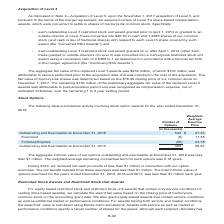According to Centurylink's financial document, What was the aggregate intrinsic value of options outstanding and exercisable at December 31, 2019?  less than $1 million. The document states: "standing and exercisable at December 31, 2019 was less than $1 million. The weighted-average remaining contractual term for such options was 0.18 year..." Also, What is the weighted-average remaining contractual term for options outstanding and exercisable? According to the financial document, 0.18 years. The relevant text states: "e remaining contractual term for such options was 0.18 years...." Also, What are the activity types involving stock option awards? The document shows two values: Exercised and Forfeited/Expired. From the document: "nd Exercisable at December 31, 2018 . 543 $ 27.46 Exercised . (6) 11.38 Forfeited/Expired . (68) 24.78 mber 31, 2018 . 543 $ 27.46 Exercised . (6) 11...." Additionally, Which year has a higher weighted-average exercise price for options outstanding and exercisable? According to the financial document, 2019. The relevant text states: "Outstanding and Exercisable at December 31, 2019 . 469 28.04..." Also, can you calculate: What is the change in the number of options outstanding and exercisable in 2019 from 2018? Based on the calculation: 469-543, the result is -74 (in thousands). This is based on the information: "utstanding and Exercisable at December 31, 2019 . 469 28.04 utstanding and Exercisable at December 31, 2018 . 543 $ 27.46 Exercised . (6) 11.38 Forfeited/Expired . (68) 24.78..." The key data points involved are: 469, 543. Also, can you calculate: What is the percentage change in the weighted-average exercise price for options outstanding and exercisable in 2019 from 2018? To answer this question, I need to perform calculations using the financial data. The calculation is: (28.04-27.46)/27.46, which equals 2.11 (percentage). This is based on the information: "anding and Exercisable at December 31, 2019 . 469 28.04 ding and Exercisable at December 31, 2018 . 543 $ 27.46 Exercised . (6) 11.38 Forfeited/Expired . (68) 24.78..." The key data points involved are: 27.46, 28.04. 